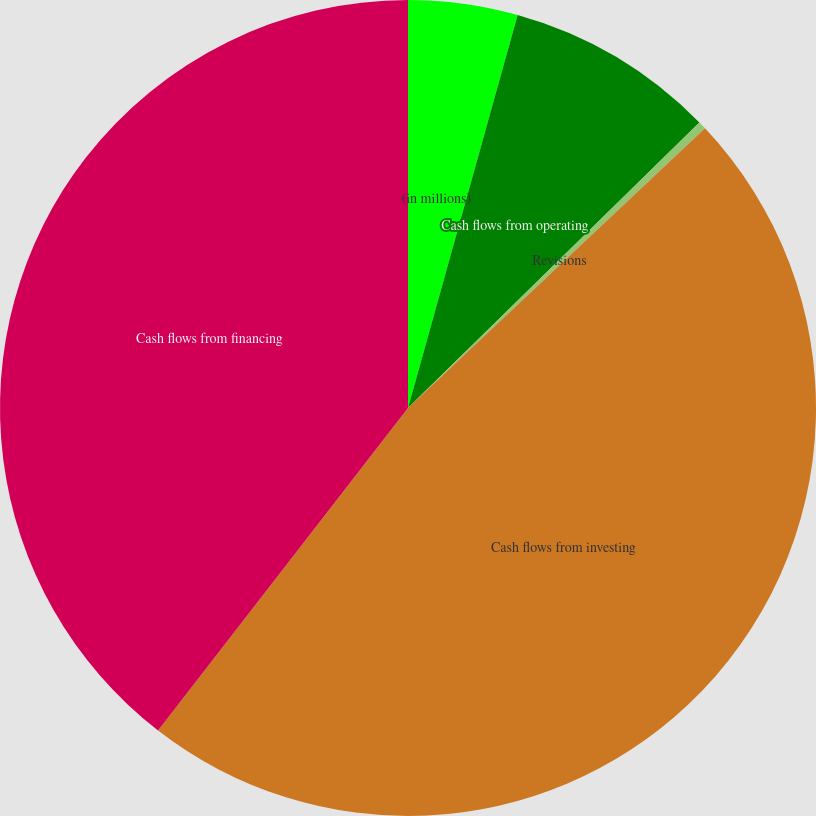<chart> <loc_0><loc_0><loc_500><loc_500><pie_chart><fcel>(in millions)<fcel>Cash flows from operating<fcel>Revisions<fcel>Cash flows from investing<fcel>Cash flows from financing<nl><fcel>4.33%<fcel>8.33%<fcel>0.32%<fcel>47.52%<fcel>39.51%<nl></chart> 